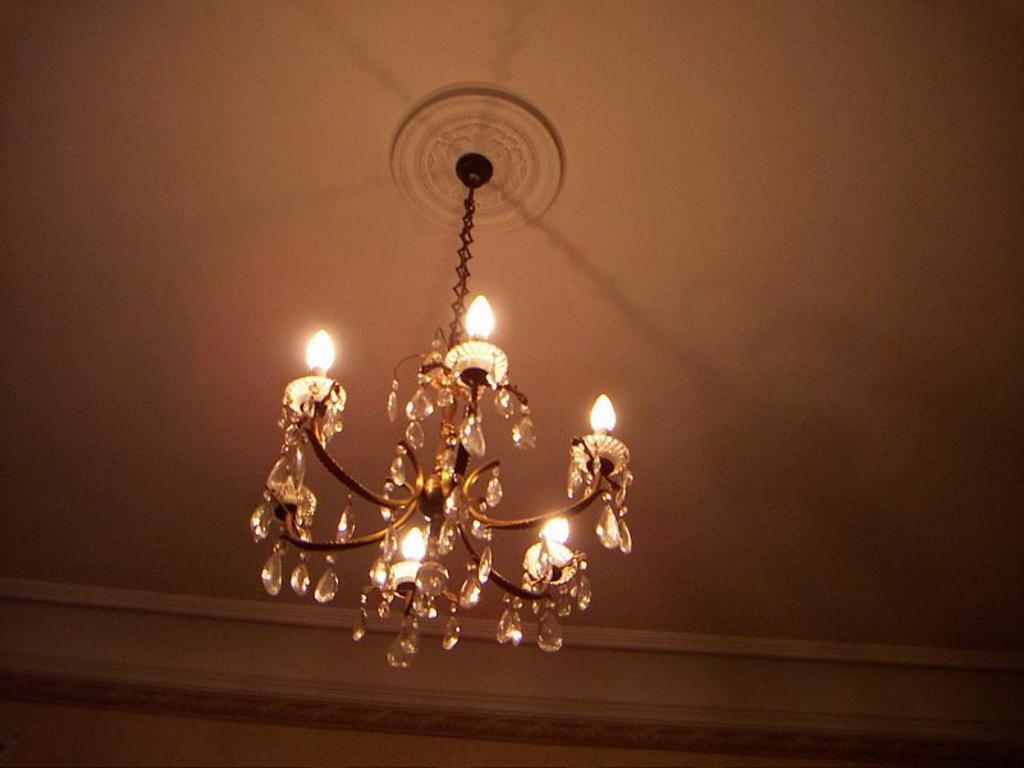In one or two sentences, can you explain what this image depicts? In this image, I can see a chandelier, which is hanging to the roof. I think this is an iron chain. 